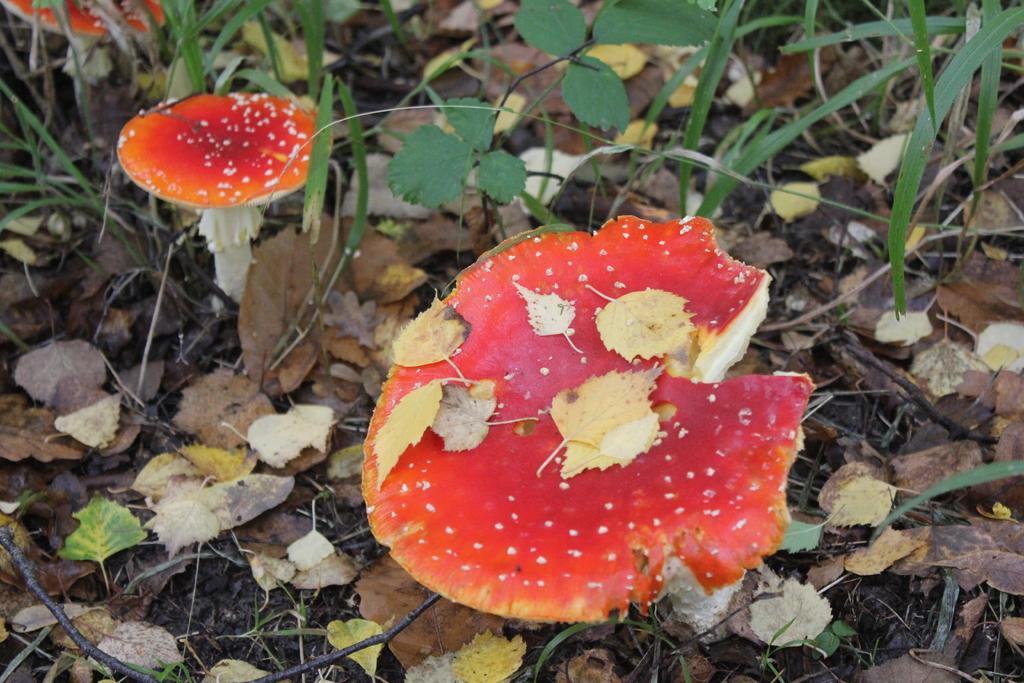Please provide a concise description of this image. In the image there are mushrooms on the dry grassland. 